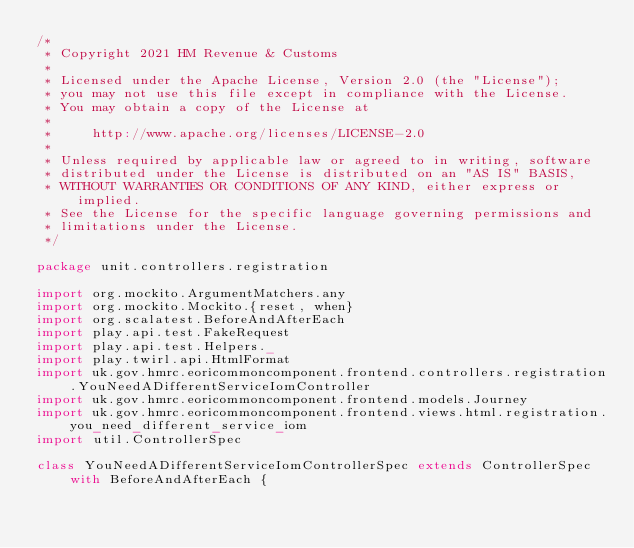Convert code to text. <code><loc_0><loc_0><loc_500><loc_500><_Scala_>/*
 * Copyright 2021 HM Revenue & Customs
 *
 * Licensed under the Apache License, Version 2.0 (the "License");
 * you may not use this file except in compliance with the License.
 * You may obtain a copy of the License at
 *
 *     http://www.apache.org/licenses/LICENSE-2.0
 *
 * Unless required by applicable law or agreed to in writing, software
 * distributed under the License is distributed on an "AS IS" BASIS,
 * WITHOUT WARRANTIES OR CONDITIONS OF ANY KIND, either express or implied.
 * See the License for the specific language governing permissions and
 * limitations under the License.
 */

package unit.controllers.registration

import org.mockito.ArgumentMatchers.any
import org.mockito.Mockito.{reset, when}
import org.scalatest.BeforeAndAfterEach
import play.api.test.FakeRequest
import play.api.test.Helpers._
import play.twirl.api.HtmlFormat
import uk.gov.hmrc.eoricommoncomponent.frontend.controllers.registration.YouNeedADifferentServiceIomController
import uk.gov.hmrc.eoricommoncomponent.frontend.models.Journey
import uk.gov.hmrc.eoricommoncomponent.frontend.views.html.registration.you_need_different_service_iom
import util.ControllerSpec

class YouNeedADifferentServiceIomControllerSpec extends ControllerSpec with BeforeAndAfterEach {
</code> 